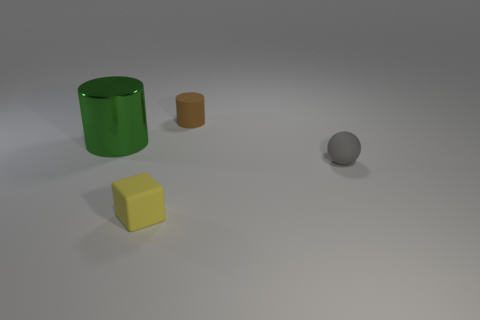Add 2 tiny gray rubber spheres. How many objects exist? 6 Subtract all balls. How many objects are left? 3 Add 2 big red balls. How many big red balls exist? 2 Subtract 0 blue cubes. How many objects are left? 4 Subtract all large green balls. Subtract all big cylinders. How many objects are left? 3 Add 2 matte balls. How many matte balls are left? 3 